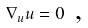<formula> <loc_0><loc_0><loc_500><loc_500>\nabla _ { u } u = 0 \text {  ,}</formula> 